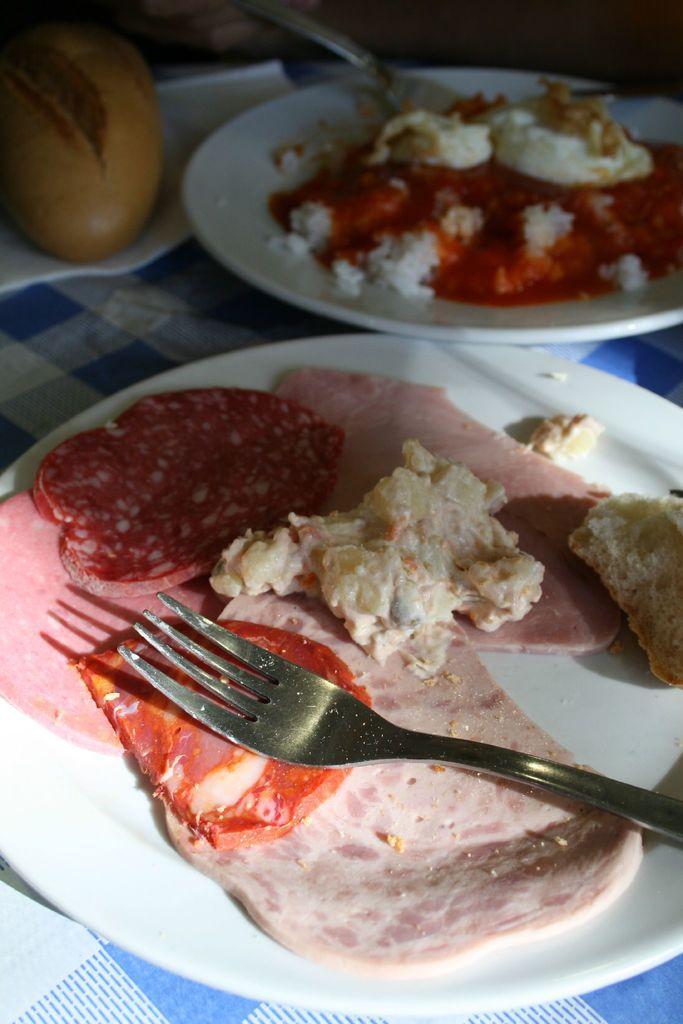Please provide a concise description of this image. In this image, we can see some food items in plates are placed on some cloth. We can also see an object in the top left corner. We can also see some forks. 